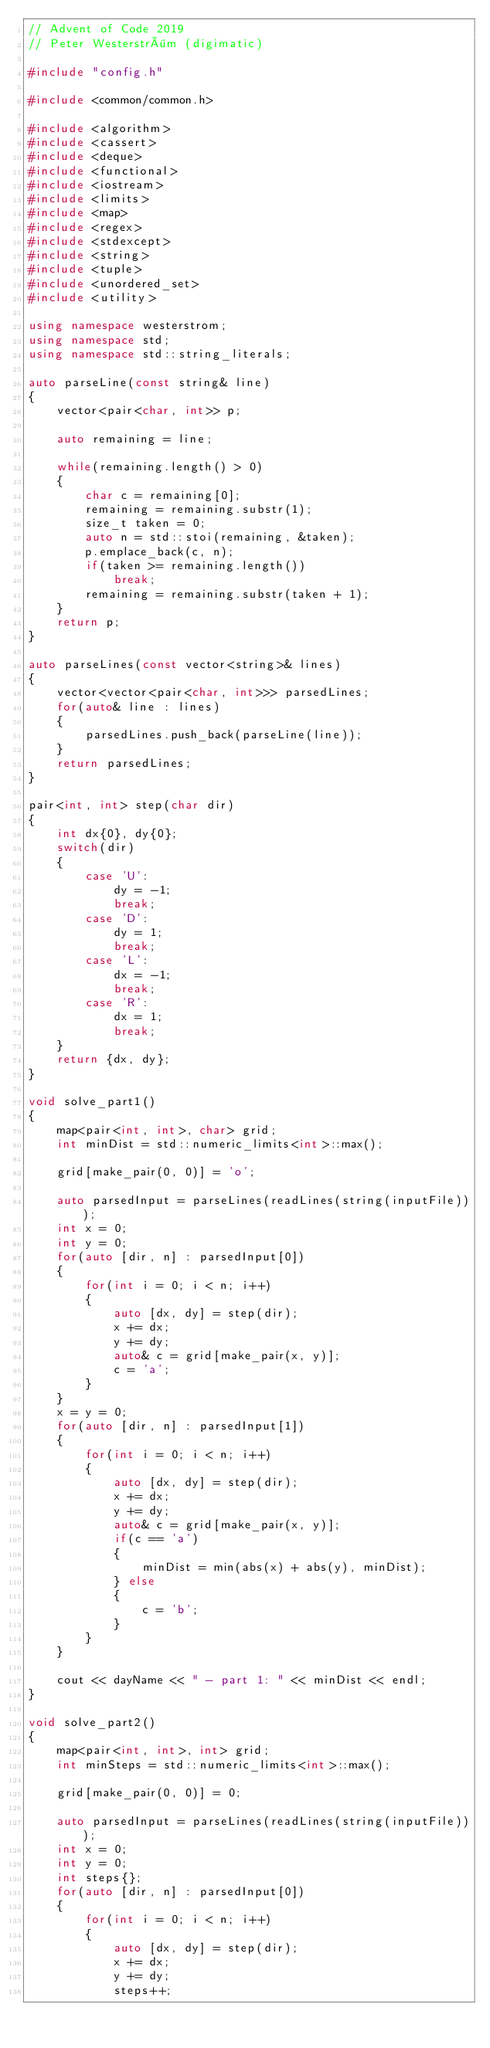Convert code to text. <code><loc_0><loc_0><loc_500><loc_500><_C++_>// Advent of Code 2019
// Peter Westerström (digimatic)

#include "config.h"

#include <common/common.h>

#include <algorithm>
#include <cassert>
#include <deque>
#include <functional>
#include <iostream>
#include <limits>
#include <map>
#include <regex>
#include <stdexcept>
#include <string>
#include <tuple>
#include <unordered_set>
#include <utility>

using namespace westerstrom;
using namespace std;
using namespace std::string_literals;

auto parseLine(const string& line)
{
	vector<pair<char, int>> p;

	auto remaining = line;

	while(remaining.length() > 0)
	{
		char c = remaining[0];
		remaining = remaining.substr(1);
		size_t taken = 0;
		auto n = std::stoi(remaining, &taken);
		p.emplace_back(c, n);
		if(taken >= remaining.length())
			break;
		remaining = remaining.substr(taken + 1);
	}
	return p;
}

auto parseLines(const vector<string>& lines)
{
	vector<vector<pair<char, int>>> parsedLines;
	for(auto& line : lines)
	{
		parsedLines.push_back(parseLine(line));
	}
	return parsedLines;
}

pair<int, int> step(char dir)
{
	int dx{0}, dy{0};
	switch(dir)
	{
		case 'U':
			dy = -1;
			break;
		case 'D':
			dy = 1;
			break;
		case 'L':
			dx = -1;
			break;
		case 'R':
			dx = 1;
			break;
	}
	return {dx, dy};
}

void solve_part1()
{
	map<pair<int, int>, char> grid;
	int minDist = std::numeric_limits<int>::max();

	grid[make_pair(0, 0)] = 'o';

	auto parsedInput = parseLines(readLines(string(inputFile)));
	int x = 0;
	int y = 0;
	for(auto [dir, n] : parsedInput[0])
	{
		for(int i = 0; i < n; i++)
		{
			auto [dx, dy] = step(dir);
			x += dx;
			y += dy;
			auto& c = grid[make_pair(x, y)];
			c = 'a';
		}
	}
	x = y = 0;
	for(auto [dir, n] : parsedInput[1])
	{
		for(int i = 0; i < n; i++)
		{
			auto [dx, dy] = step(dir);
			x += dx;
			y += dy;
			auto& c = grid[make_pair(x, y)];
			if(c == 'a')
			{
				minDist = min(abs(x) + abs(y), minDist);
			} else
			{
				c = 'b';
			}
		}
	}

	cout << dayName << " - part 1: " << minDist << endl;
}

void solve_part2()
{
	map<pair<int, int>, int> grid;
	int minSteps = std::numeric_limits<int>::max();

	grid[make_pair(0, 0)] = 0;

	auto parsedInput = parseLines(readLines(string(inputFile)));
	int x = 0;
	int y = 0;
	int steps{};
	for(auto [dir, n] : parsedInput[0])
	{
		for(int i = 0; i < n; i++)
		{
			auto [dx, dy] = step(dir);
			x += dx;
			y += dy;
			steps++;</code> 